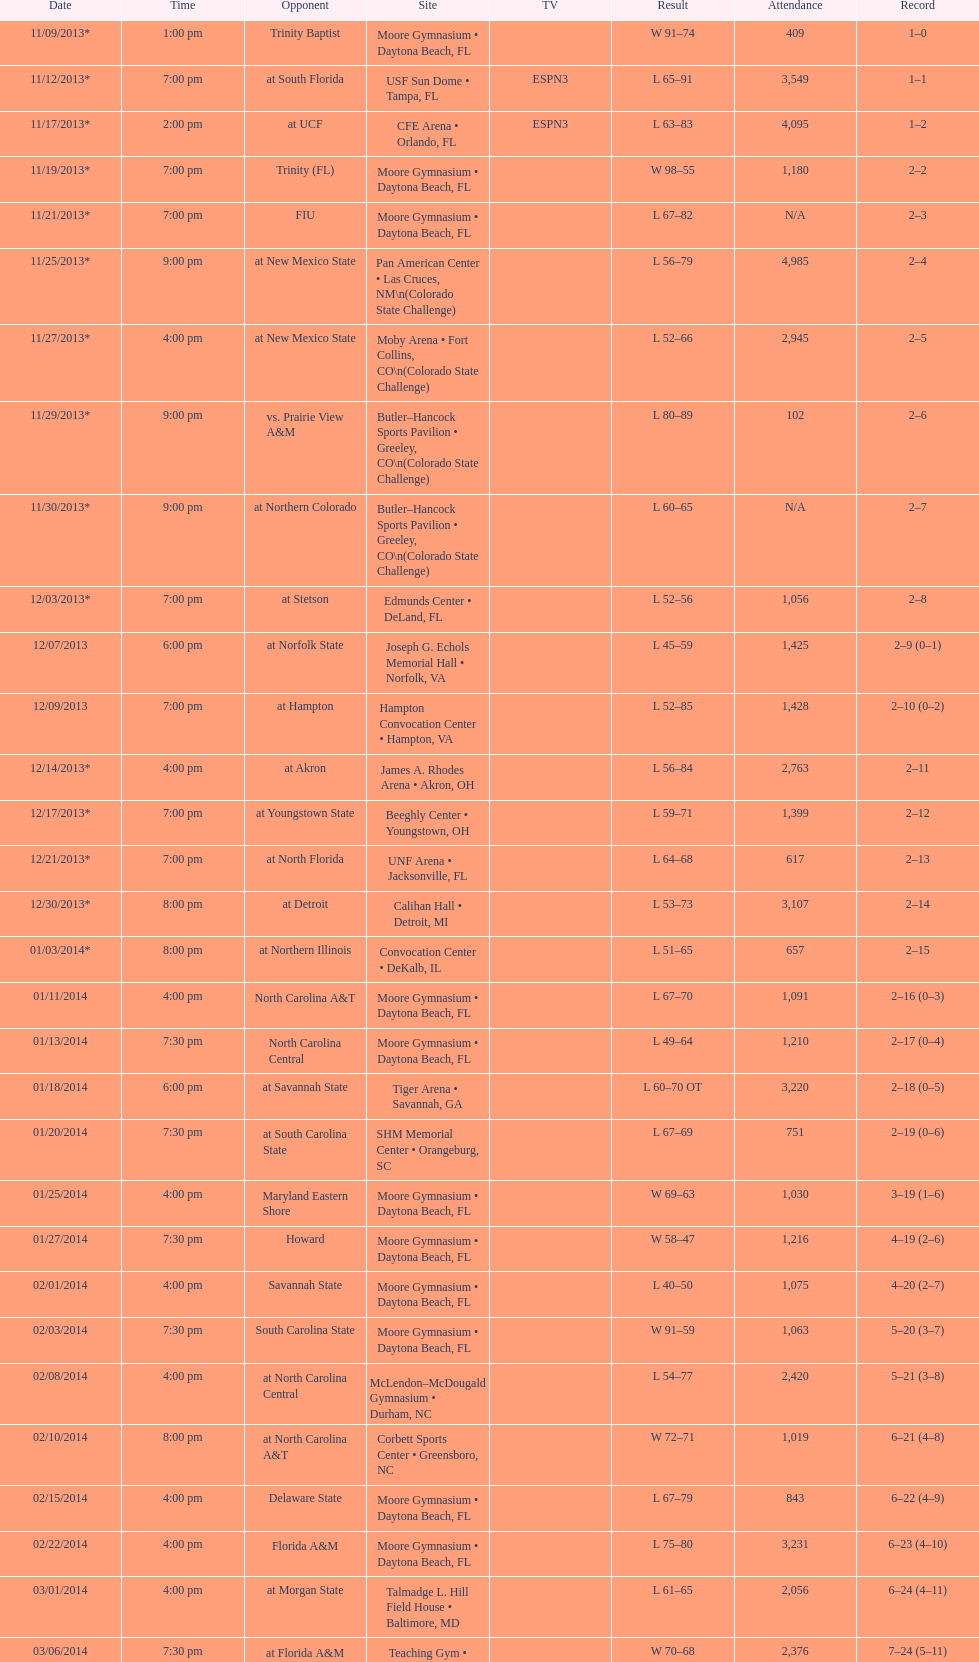How many games did the wildcats play in daytona beach, fl? 11. Can you give me this table as a dict? {'header': ['Date', 'Time', 'Opponent', 'Site', 'TV', 'Result', 'Attendance', 'Record'], 'rows': [['11/09/2013*', '1:00 pm', 'Trinity Baptist', 'Moore Gymnasium • Daytona Beach, FL', '', 'W\xa091–74', '409', '1–0'], ['11/12/2013*', '7:00 pm', 'at\xa0South Florida', 'USF Sun Dome • Tampa, FL', 'ESPN3', 'L\xa065–91', '3,549', '1–1'], ['11/17/2013*', '2:00 pm', 'at\xa0UCF', 'CFE Arena • Orlando, FL', 'ESPN3', 'L\xa063–83', '4,095', '1–2'], ['11/19/2013*', '7:00 pm', 'Trinity (FL)', 'Moore Gymnasium • Daytona Beach, FL', '', 'W\xa098–55', '1,180', '2–2'], ['11/21/2013*', '7:00 pm', 'FIU', 'Moore Gymnasium • Daytona Beach, FL', '', 'L\xa067–82', 'N/A', '2–3'], ['11/25/2013*', '9:00 pm', 'at\xa0New Mexico State', 'Pan American Center • Las Cruces, NM\\n(Colorado State Challenge)', '', 'L\xa056–79', '4,985', '2–4'], ['11/27/2013*', '4:00 pm', 'at\xa0New Mexico State', 'Moby Arena • Fort Collins, CO\\n(Colorado State Challenge)', '', 'L\xa052–66', '2,945', '2–5'], ['11/29/2013*', '9:00 pm', 'vs.\xa0Prairie View A&M', 'Butler–Hancock Sports Pavilion • Greeley, CO\\n(Colorado State Challenge)', '', 'L\xa080–89', '102', '2–6'], ['11/30/2013*', '9:00 pm', 'at\xa0Northern Colorado', 'Butler–Hancock Sports Pavilion • Greeley, CO\\n(Colorado State Challenge)', '', 'L\xa060–65', 'N/A', '2–7'], ['12/03/2013*', '7:00 pm', 'at\xa0Stetson', 'Edmunds Center • DeLand, FL', '', 'L\xa052–56', '1,056', '2–8'], ['12/07/2013', '6:00 pm', 'at\xa0Norfolk State', 'Joseph G. Echols Memorial Hall • Norfolk, VA', '', 'L\xa045–59', '1,425', '2–9 (0–1)'], ['12/09/2013', '7:00 pm', 'at\xa0Hampton', 'Hampton Convocation Center • Hampton, VA', '', 'L\xa052–85', '1,428', '2–10 (0–2)'], ['12/14/2013*', '4:00 pm', 'at\xa0Akron', 'James A. Rhodes Arena • Akron, OH', '', 'L\xa056–84', '2,763', '2–11'], ['12/17/2013*', '7:00 pm', 'at\xa0Youngstown State', 'Beeghly Center • Youngstown, OH', '', 'L\xa059–71', '1,399', '2–12'], ['12/21/2013*', '7:00 pm', 'at\xa0North Florida', 'UNF Arena • Jacksonville, FL', '', 'L\xa064–68', '617', '2–13'], ['12/30/2013*', '8:00 pm', 'at\xa0Detroit', 'Calihan Hall • Detroit, MI', '', 'L\xa053–73', '3,107', '2–14'], ['01/03/2014*', '8:00 pm', 'at\xa0Northern Illinois', 'Convocation Center • DeKalb, IL', '', 'L\xa051–65', '657', '2–15'], ['01/11/2014', '4:00 pm', 'North Carolina A&T', 'Moore Gymnasium • Daytona Beach, FL', '', 'L\xa067–70', '1,091', '2–16 (0–3)'], ['01/13/2014', '7:30 pm', 'North Carolina Central', 'Moore Gymnasium • Daytona Beach, FL', '', 'L\xa049–64', '1,210', '2–17 (0–4)'], ['01/18/2014', '6:00 pm', 'at\xa0Savannah State', 'Tiger Arena • Savannah, GA', '', 'L\xa060–70\xa0OT', '3,220', '2–18 (0–5)'], ['01/20/2014', '7:30 pm', 'at\xa0South Carolina State', 'SHM Memorial Center • Orangeburg, SC', '', 'L\xa067–69', '751', '2–19 (0–6)'], ['01/25/2014', '4:00 pm', 'Maryland Eastern Shore', 'Moore Gymnasium • Daytona Beach, FL', '', 'W\xa069–63', '1,030', '3–19 (1–6)'], ['01/27/2014', '7:30 pm', 'Howard', 'Moore Gymnasium • Daytona Beach, FL', '', 'W\xa058–47', '1,216', '4–19 (2–6)'], ['02/01/2014', '4:00 pm', 'Savannah State', 'Moore Gymnasium • Daytona Beach, FL', '', 'L\xa040–50', '1,075', '4–20 (2–7)'], ['02/03/2014', '7:30 pm', 'South Carolina State', 'Moore Gymnasium • Daytona Beach, FL', '', 'W\xa091–59', '1,063', '5–20 (3–7)'], ['02/08/2014', '4:00 pm', 'at\xa0North Carolina Central', 'McLendon–McDougald Gymnasium • Durham, NC', '', 'L\xa054–77', '2,420', '5–21 (3–8)'], ['02/10/2014', '8:00 pm', 'at\xa0North Carolina A&T', 'Corbett Sports Center • Greensboro, NC', '', 'W\xa072–71', '1,019', '6–21 (4–8)'], ['02/15/2014', '4:00 pm', 'Delaware State', 'Moore Gymnasium • Daytona Beach, FL', '', 'L\xa067–79', '843', '6–22 (4–9)'], ['02/22/2014', '4:00 pm', 'Florida A&M', 'Moore Gymnasium • Daytona Beach, FL', '', 'L\xa075–80', '3,231', '6–23 (4–10)'], ['03/01/2014', '4:00 pm', 'at\xa0Morgan State', 'Talmadge L. Hill Field House • Baltimore, MD', '', 'L\xa061–65', '2,056', '6–24 (4–11)'], ['03/06/2014', '7:30 pm', 'at\xa0Florida A&M', 'Teaching Gym • Tallahassee, FL', '', 'W\xa070–68', '2,376', '7–24 (5–11)'], ['03/11/2014', '6:30 pm', 'vs.\xa0Coppin State', 'Norfolk Scope • Norfolk, VA\\n(First round)', '', 'L\xa068–75', '4,658', '7–25']]} 